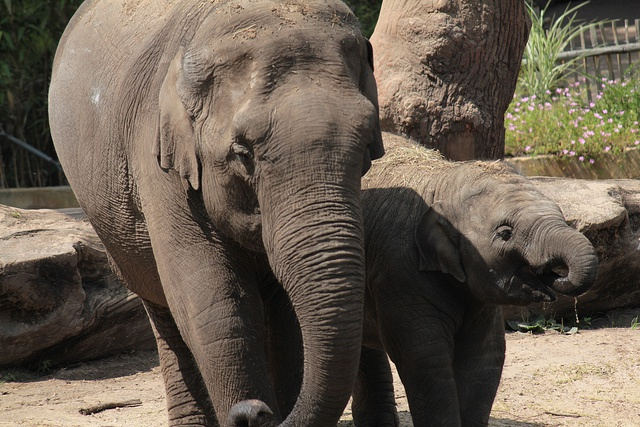Describe the objects in this image and their specific colors. I can see elephant in black, gray, and darkgray tones and elephant in black, tan, and gray tones in this image. 